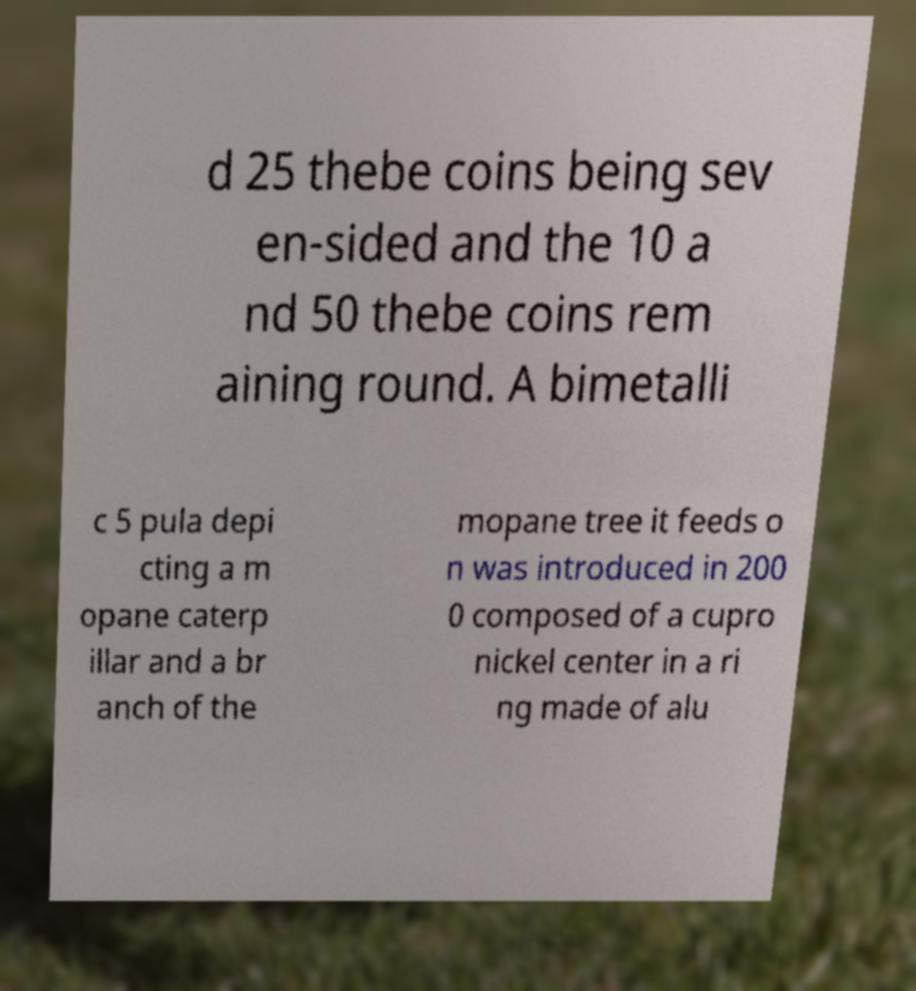I need the written content from this picture converted into text. Can you do that? d 25 thebe coins being sev en-sided and the 10 a nd 50 thebe coins rem aining round. A bimetalli c 5 pula depi cting a m opane caterp illar and a br anch of the mopane tree it feeds o n was introduced in 200 0 composed of a cupro nickel center in a ri ng made of alu 